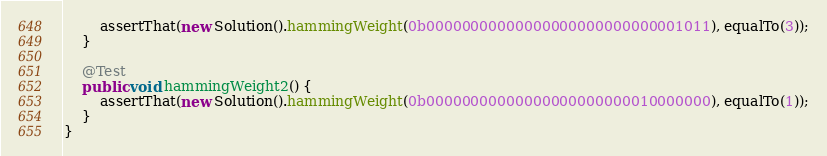Convert code to text. <code><loc_0><loc_0><loc_500><loc_500><_Java_>        assertThat(new Solution().hammingWeight(0b00000000000000000000000000001011), equalTo(3));
    }

    @Test
    public void hammingWeight2() {
        assertThat(new Solution().hammingWeight(0b00000000000000000000000010000000), equalTo(1));
    }
}
</code> 